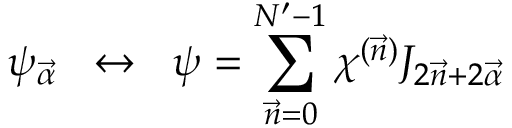Convert formula to latex. <formula><loc_0><loc_0><loc_500><loc_500>\psi _ { \vec { \alpha } } \, \leftrightarrow \, \psi = \sum _ { \vec { n } = 0 } ^ { N ^ { \prime } - 1 } \chi ^ { ( \vec { n } ) } J _ { 2 \vec { n } + 2 \vec { \alpha } }</formula> 